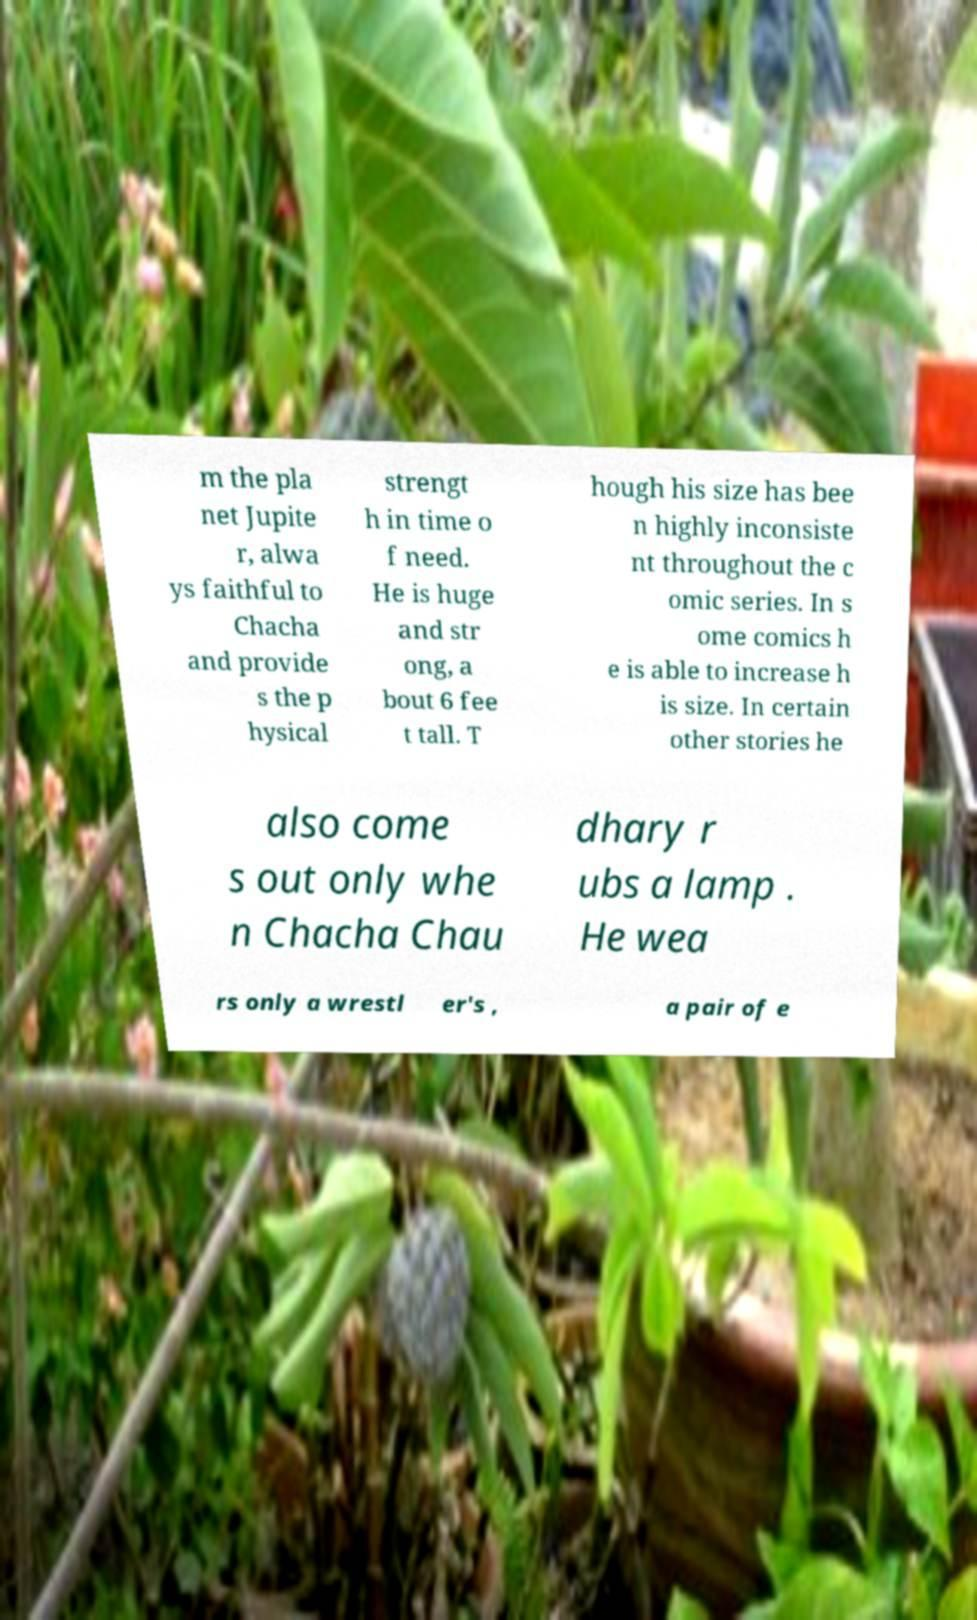I need the written content from this picture converted into text. Can you do that? m the pla net Jupite r, alwa ys faithful to Chacha and provide s the p hysical strengt h in time o f need. He is huge and str ong, a bout 6 fee t tall. T hough his size has bee n highly inconsiste nt throughout the c omic series. In s ome comics h e is able to increase h is size. In certain other stories he also come s out only whe n Chacha Chau dhary r ubs a lamp . He wea rs only a wrestl er's , a pair of e 